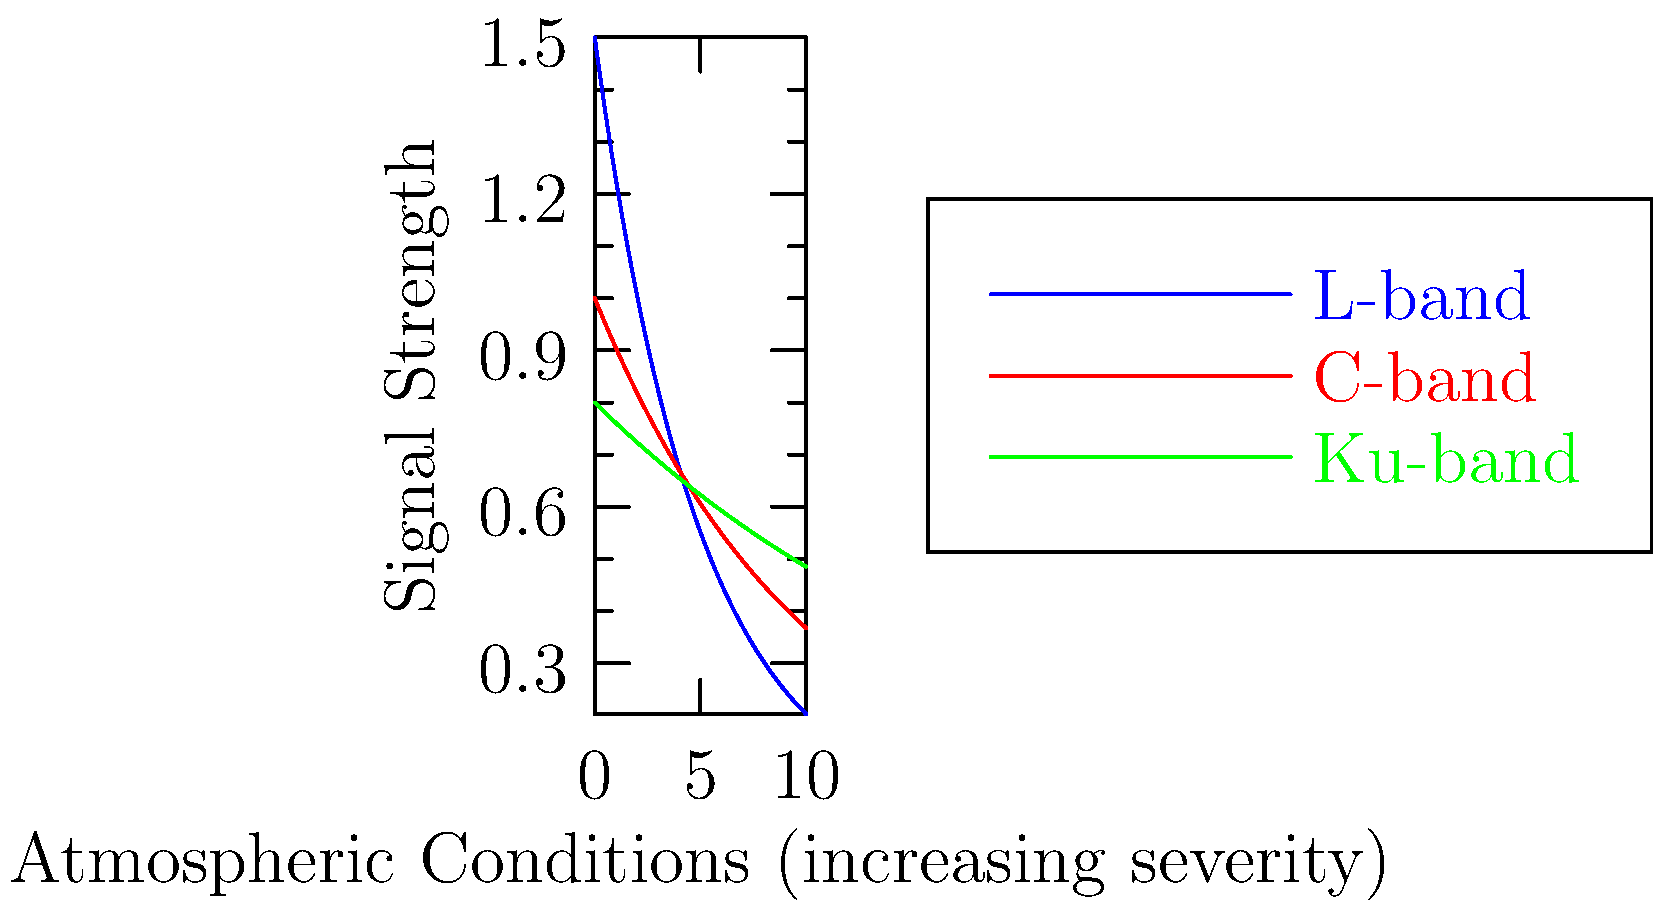Based on the graph showing signal strength of different satellite frequencies across various atmospheric conditions, which frequency band demonstrates the highest resilience to deteriorating atmospheric conditions? To determine which frequency band is most resilient to deteriorating atmospheric conditions, we need to analyze the graph:

1. The x-axis represents increasing severity of atmospheric conditions.
2. The y-axis represents signal strength.
3. Three frequency bands are shown: L-band (blue), C-band (red), and Ku-band (green).

Let's examine each band:

1. L-band (blue):
   - Starts with the highest signal strength
   - Decreases rapidly as atmospheric conditions worsen

2. C-band (red):
   - Starts with medium signal strength
   - Decreases at a moderate rate

3. Ku-band (green):
   - Starts with the lowest signal strength
   - Decreases at the slowest rate

The most resilient frequency band will maintain the highest signal strength as atmospheric conditions worsen (moving right on the x-axis).

While the L-band starts strongest, it falls below both C-band and Ku-band as conditions deteriorate.

The Ku-band, despite starting lowest, maintains the highest signal strength under severe atmospheric conditions due to its slow rate of decrease.

Therefore, the Ku-band demonstrates the highest resilience to deteriorating atmospheric conditions.
Answer: Ku-band 